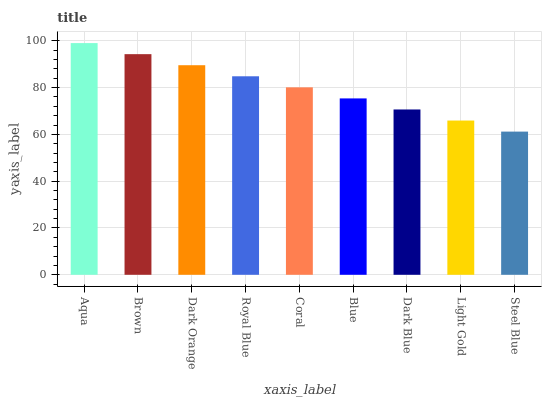Is Steel Blue the minimum?
Answer yes or no. Yes. Is Aqua the maximum?
Answer yes or no. Yes. Is Brown the minimum?
Answer yes or no. No. Is Brown the maximum?
Answer yes or no. No. Is Aqua greater than Brown?
Answer yes or no. Yes. Is Brown less than Aqua?
Answer yes or no. Yes. Is Brown greater than Aqua?
Answer yes or no. No. Is Aqua less than Brown?
Answer yes or no. No. Is Coral the high median?
Answer yes or no. Yes. Is Coral the low median?
Answer yes or no. Yes. Is Royal Blue the high median?
Answer yes or no. No. Is Royal Blue the low median?
Answer yes or no. No. 